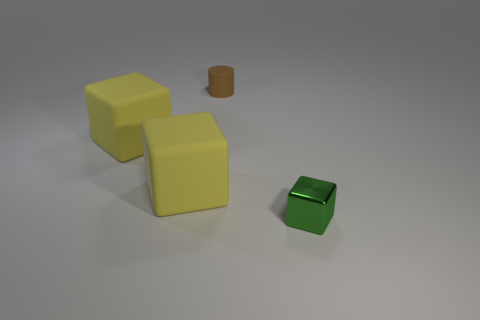What number of brown things are either small things or small cylinders?
Provide a succinct answer. 1. There is a tiny object that is behind the tiny cube; what number of large objects are behind it?
Offer a terse response. 0. How many other things are there of the same shape as the small green object?
Provide a succinct answer. 2. How many large rubber things are the same color as the tiny rubber cylinder?
Your response must be concise. 0. Are there any brown rubber cylinders of the same size as the metallic cube?
Make the answer very short. Yes. Are there more blocks that are to the right of the brown rubber cylinder than small blocks that are left of the shiny object?
Offer a terse response. Yes. Does the small thing in front of the small cylinder have the same material as the small object behind the tiny green shiny thing?
Offer a very short reply. No. The metal object that is the same size as the brown rubber cylinder is what shape?
Your response must be concise. Cube. Is there another object of the same shape as the tiny green thing?
Your response must be concise. Yes. Is the color of the small thing on the left side of the metal block the same as the thing that is right of the matte cylinder?
Offer a very short reply. No. 